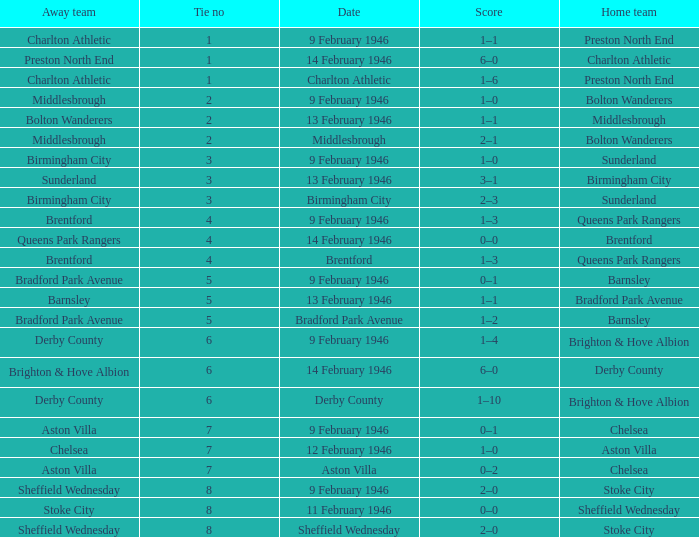What was the highest Tie no when the home team was the Bolton Wanderers, and the date was Middlesbrough? 2.0. 